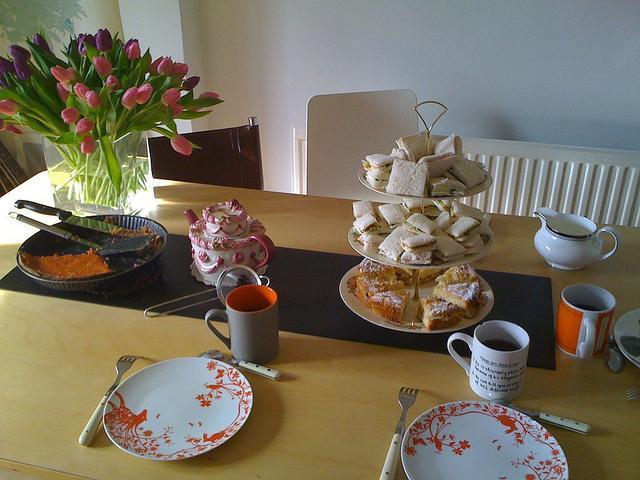How many cups on the table?
Give a very brief answer. 3. How many cups are in the picture?
Give a very brief answer. 2. How many chairs are in the picture?
Give a very brief answer. 2. How many cakes can be seen?
Give a very brief answer. 2. 